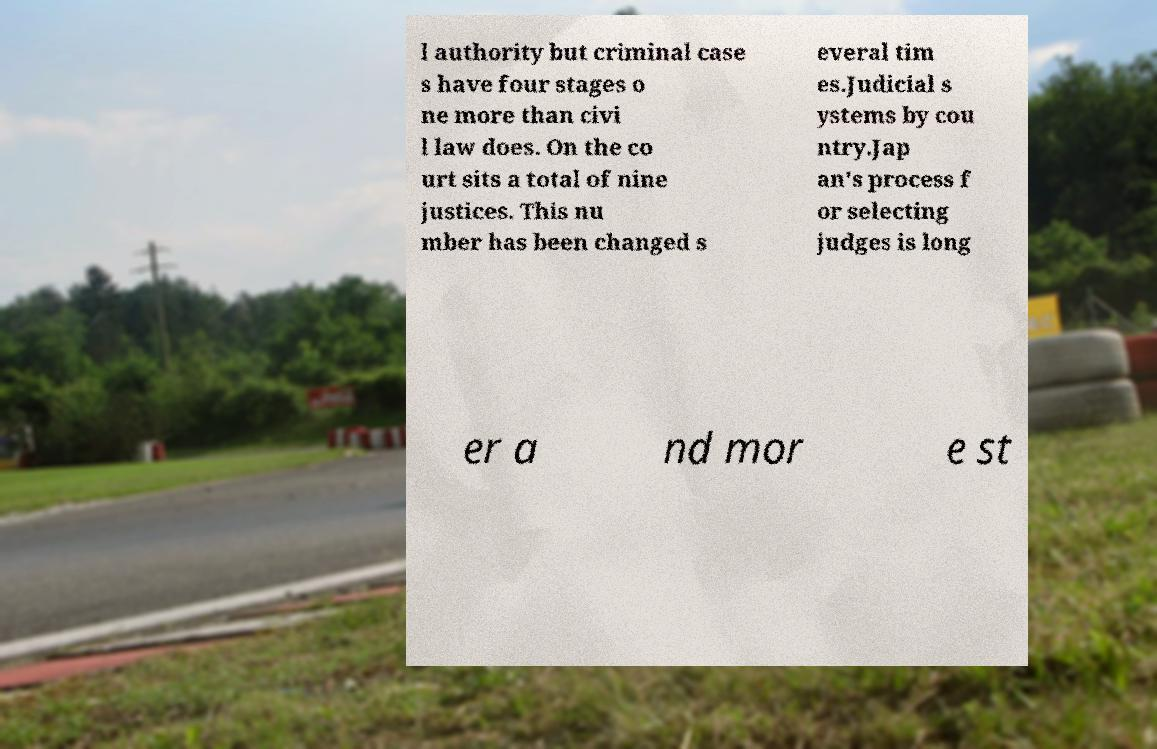Can you read and provide the text displayed in the image?This photo seems to have some interesting text. Can you extract and type it out for me? l authority but criminal case s have four stages o ne more than civi l law does. On the co urt sits a total of nine justices. This nu mber has been changed s everal tim es.Judicial s ystems by cou ntry.Jap an's process f or selecting judges is long er a nd mor e st 